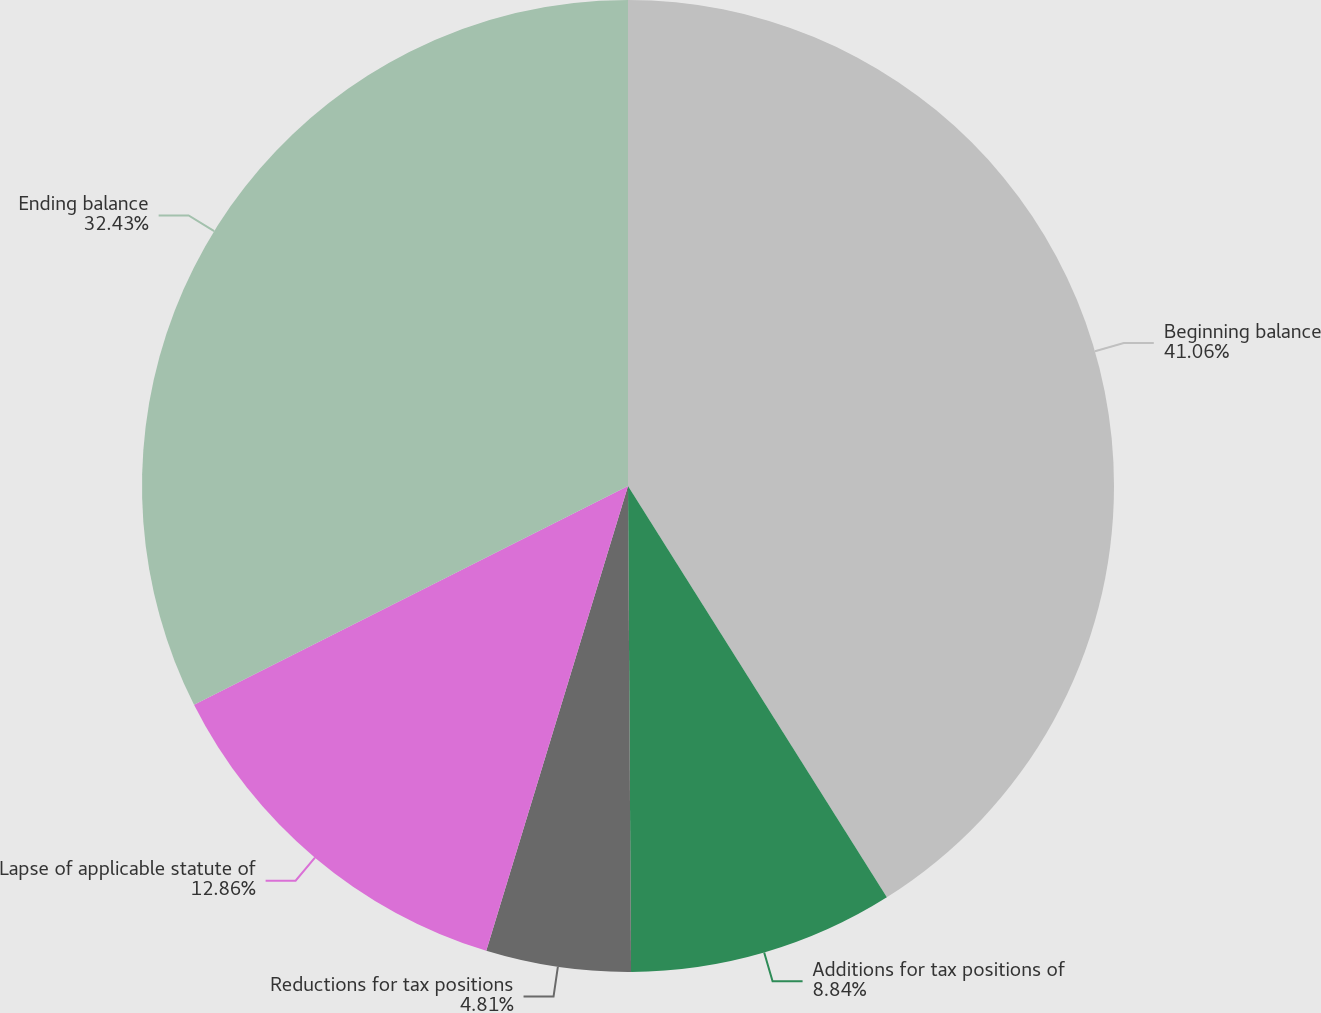Convert chart. <chart><loc_0><loc_0><loc_500><loc_500><pie_chart><fcel>Beginning balance<fcel>Additions for tax positions of<fcel>Reductions for tax positions<fcel>Lapse of applicable statute of<fcel>Ending balance<nl><fcel>41.06%<fcel>8.84%<fcel>4.81%<fcel>12.86%<fcel>32.43%<nl></chart> 